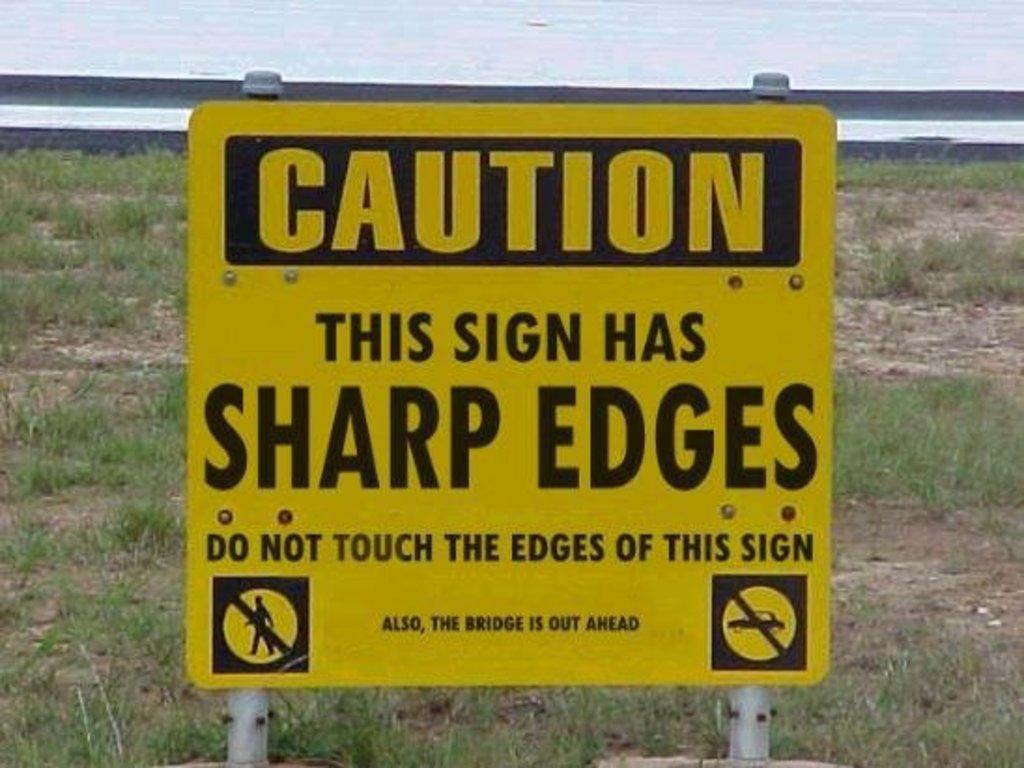<image>
Render a clear and concise summary of the photo. A yellow sign cautioning people that the sign has sharp edges and not to touch them, and in very small text that the bridge is out ahead. 